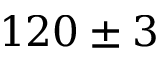<formula> <loc_0><loc_0><loc_500><loc_500>1 2 0 \pm 3</formula> 